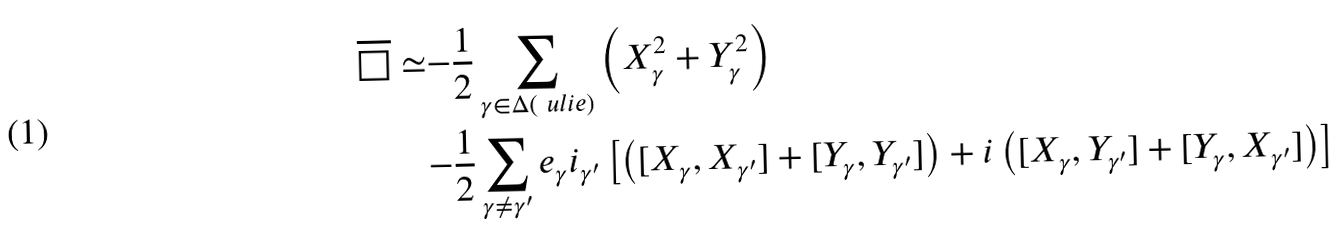Convert formula to latex. <formula><loc_0><loc_0><loc_500><loc_500>\overline { \square } \simeq & { - \frac { 1 } { 2 } } \sum _ { \gamma \in \Delta ( \ u l i e ) } \left ( X _ { \gamma } ^ { 2 } + Y _ { \gamma } ^ { 2 } \right ) \\ & { - \frac { 1 } { 2 } } \sum _ { \gamma \neq \gamma ^ { \prime } } e _ { \gamma } i _ { \gamma ^ { \prime } } \left [ \left ( [ X _ { \gamma } , X _ { \gamma ^ { \prime } } ] + [ Y _ { \gamma } , Y _ { \gamma ^ { \prime } } ] \right ) + i \left ( [ X _ { \gamma } , Y _ { \gamma ^ { \prime } } ] + [ Y _ { \gamma } , X _ { \gamma ^ { \prime } } ] \right ) \right ]</formula> 